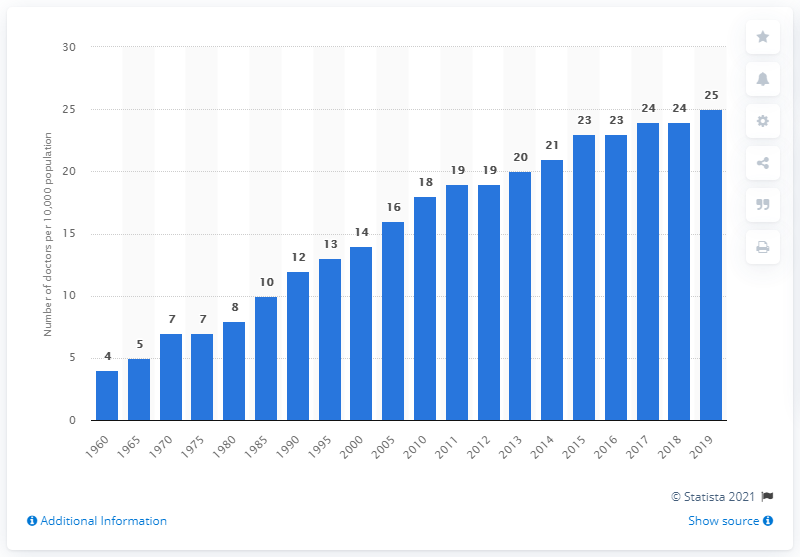Mention a couple of crucial points in this snapshot. In 2019, Singapore's density of doctors per 10,000 inhabitants was 25. 